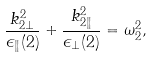<formula> <loc_0><loc_0><loc_500><loc_500>\frac { k _ { 2 \bot } ^ { 2 } } { \epsilon _ { \| } ( 2 ) } + \frac { k _ { 2 \| } ^ { 2 } } { \epsilon _ { \bot } ( 2 ) } = \omega _ { 2 } ^ { 2 } ,</formula> 